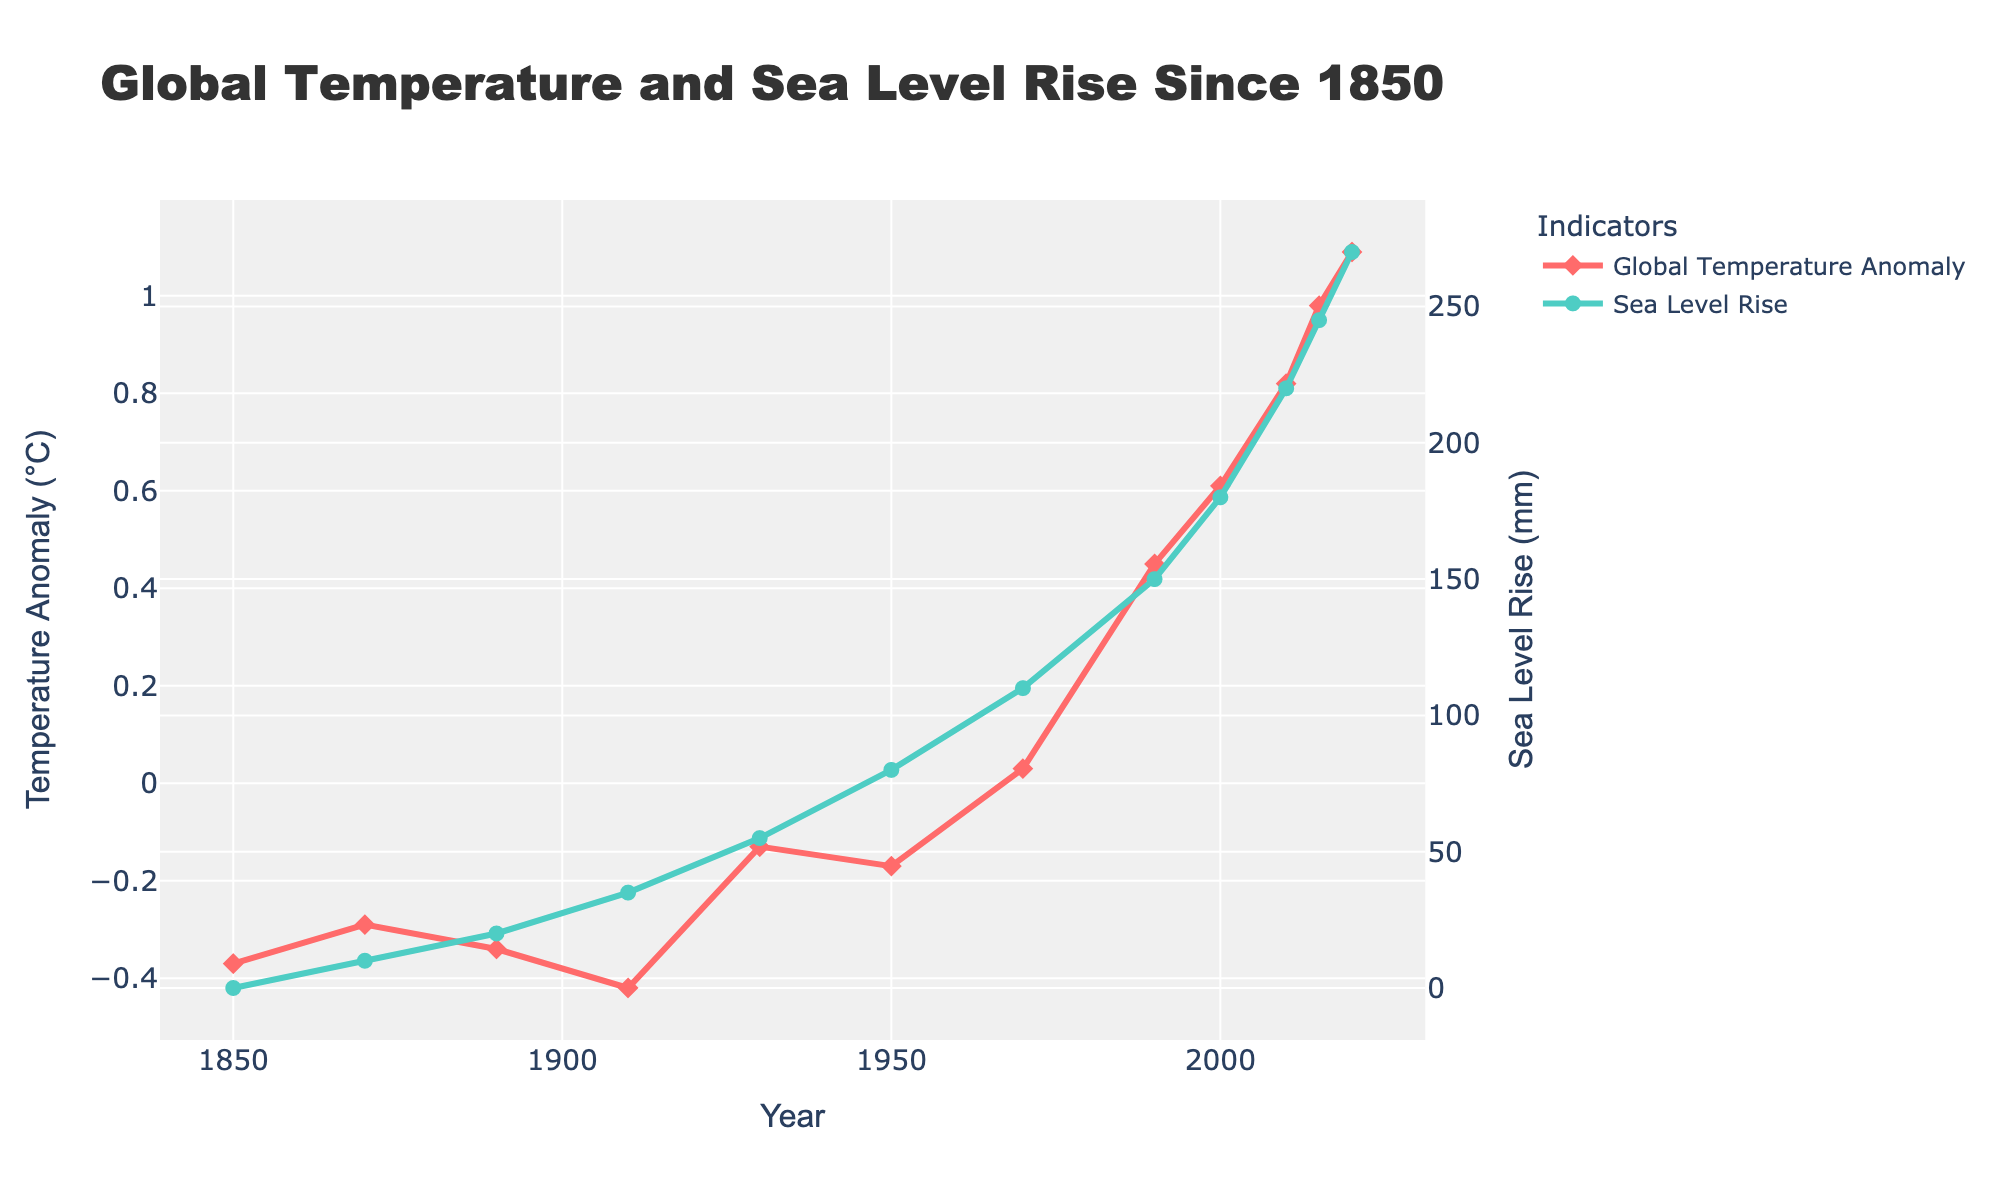What is the difference in global temperature anomaly between 1850 and 2020? To find the difference, subtract the 1850 value (-0.37°C) from the 2020 value (1.09°C). Therefore, 1.09 - (-0.37) = 1.46
Answer: 1.46°C How has the sea level risen between 1870 and 2010? Subtract the 1870 sea level rise (10 mm) from the 2010 sea level rise (220 mm). Therefore, 220 - 10 = 210
Answer: 210 mm Which indicator experienced a greater magnitude of change from 1850 to 2020, temperature anomaly or sea level rise? Calculate the absolute change for both indicators: Temperature anomaly changed from -0.37°C to 1.09°C, which is 1.09 - (-0.37) = 1.46°C. Sea level rise changed from 0 mm to 270 mm, which is 270 mm. The sea level rise experienced a greater magnitude of change.
Answer: Sea level rise What was the temperature anomaly in 2015 and how does it compare to 1990? The temperature anomaly in 2015 was 0.98°C, while in 1990 it was 0.45°C. The difference is 0.98 - 0.45 = 0.53°C.
Answer: 0.53°C higher During which 20-year interval did the sea level rise increase the most? Calculate the increase for each 20-year interval:
1870-1890: 20 - 10 = 10 mm,
1890-1910: 35 - 20 = 15 mm,
1910-1930: 55 - 35 = 20 mm,
1930-1950: 80 - 55 = 25 mm,
1950-1970: 110 - 80 = 30 mm,
1970-1990: 150 - 110 = 40 mm,
1990-2010: 220 - 150 = 70 mm.
The greatest increase was between 1990 and 2010.
Answer: 1990-2010 At what time period did the temperature anomaly cross from negative to positive? The temperature anomaly crossed from negative to positive between 1950 (-0.17°C) and 1970 (0.03°C).
Answer: Between 1950 and 1970 Between which years did the sea level increase during the observed period appear to be fastest? Identify the steepest segment in the graph. The rise appears steeper between 1990 (150 mm) and 2010 (220 mm).
Answer: Between 1990 and 2010 